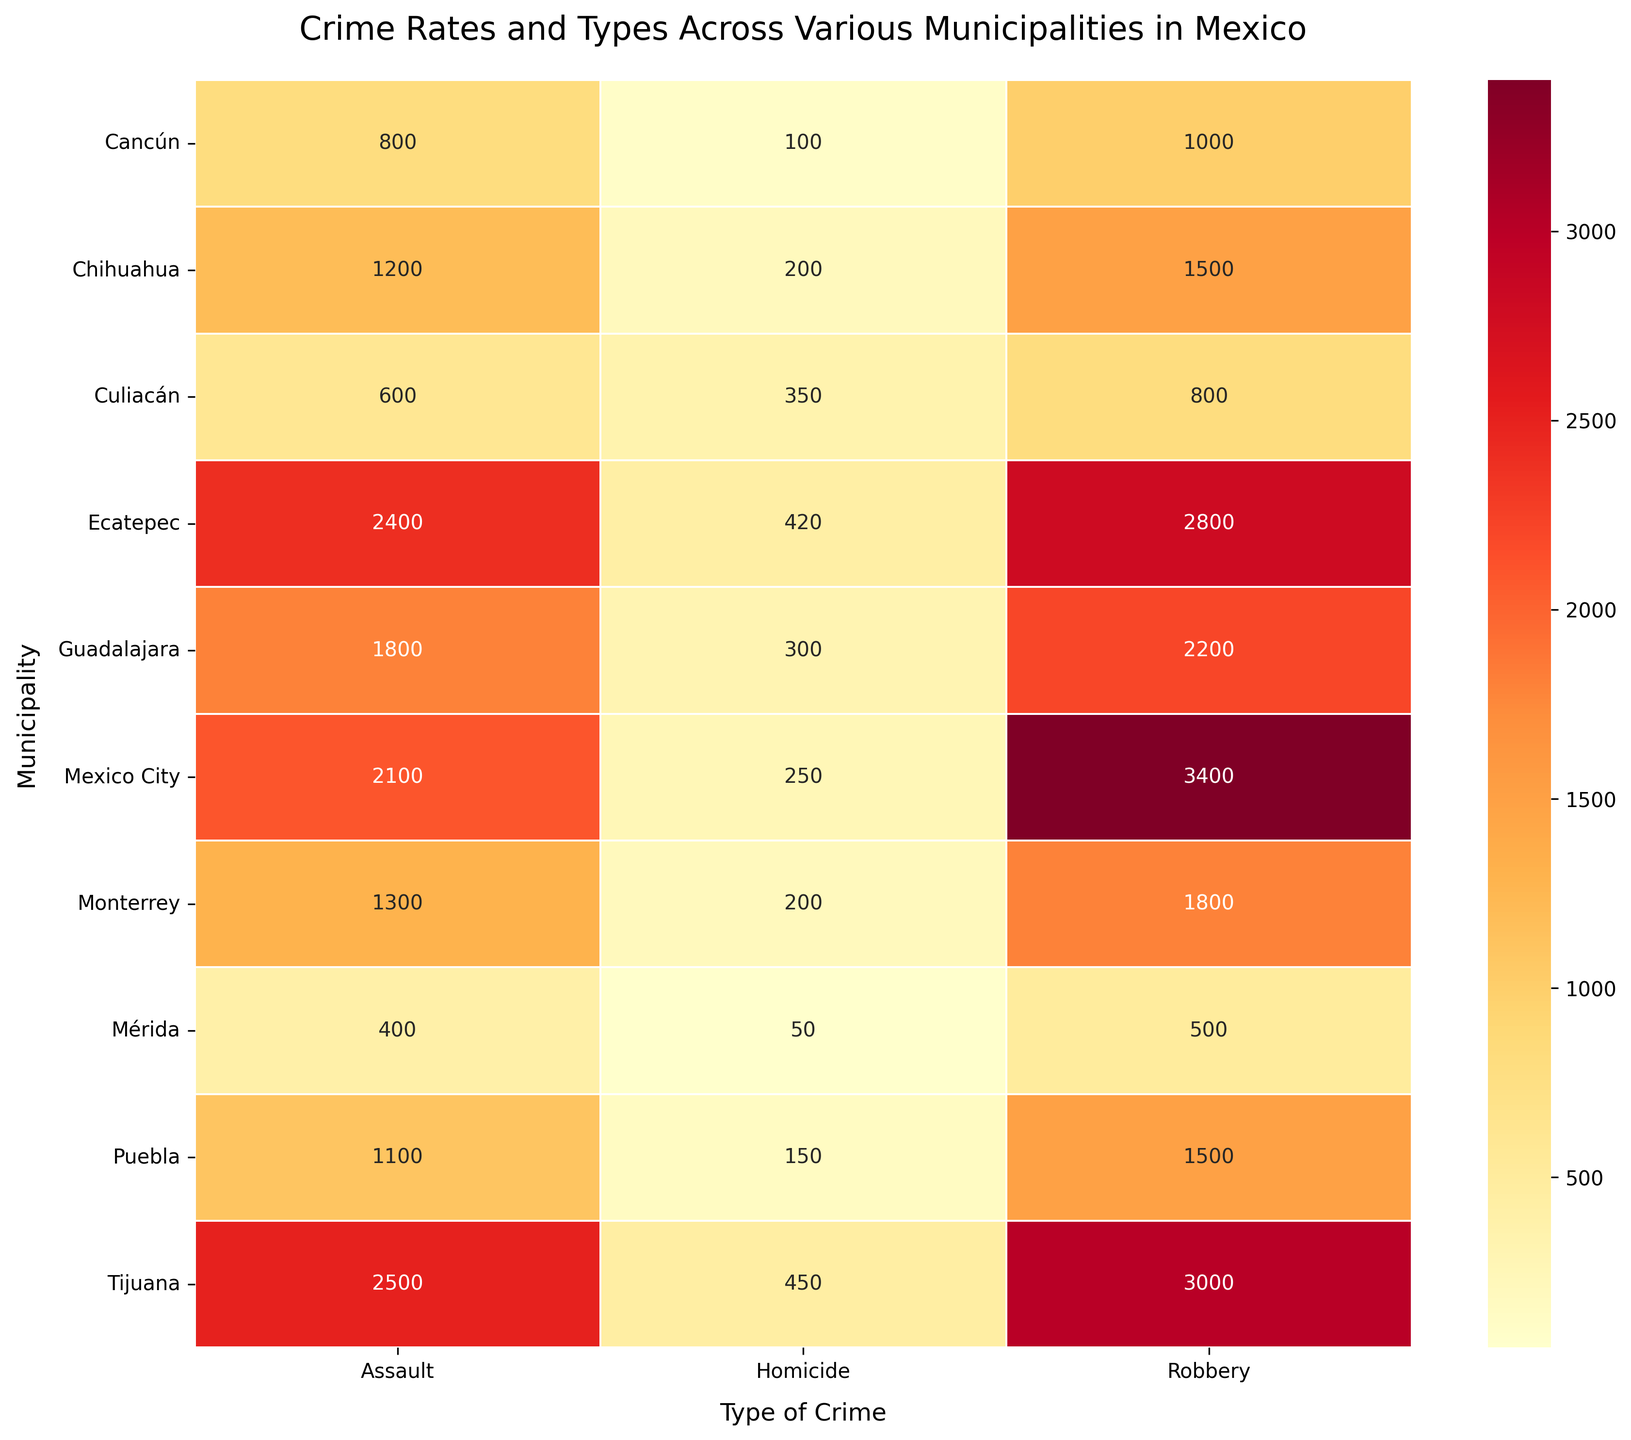How many types of crime are represented in the heatmap? The heatmap visualizes data for three types of crime: Robbery, Assault, and Homicide as seen on the x-axis.
Answer: Three types of crime Which municipality has the highest number of homicides? By examining the "Homicide" column, Tijuana has the highest number of incidents with 450.
Answer: Tijuana What is the total number of robbery incidents in Ecatepec and Guadalajara combined? Ecatepec has 2800 robbery incidents and Guadalajara has 2200. Summing them gives 2800 + 2200 = 5000.
Answer: 5000 Among Monterrey and Puebla, which municipality has fewer total number of crimes? Add the incidents for each type of crime for Monterrey: 1800 (Robbery) + 1300 (Assault) + 200 (Homicide) = 3300. For Puebla: 1500 (Robbery) + 1100 (Assault) + 150 (Homicide) = 2750. Puebla has fewer total incidents.
Answer: Puebla What is the most common type of crime in Mexico City? In the rows for Mexico City, the highest number of incidents is associated with robbery (3400).
Answer: Robbery Which type of crime shows the largest variation across all municipalities? By visually scanning the heatmap colors in each crime column, robbery shows the largest variation, with some municipalities having as high as 3400 incidents and others as low as 500.
Answer: Robbery How does the number of assault incidents in Tijuana compare to that in Guadalajara? Tijuana has 2500 assault incidents while Guadalajara has 1800, so Tijuana has more assault incidents.
Answer: Tijuana has more What is the average number of homicides across all municipalities depicted? Sum the numbers in the homicide column: 250 (Mexico City) + 300 (Guadalajara) + 200 (Monterrey) + 150 (Puebla) + 450 (Tijuana) + 420 (Ecatepec) + 100 (Cancún) + 50 (Mérida) + 200 (Chihuahua) + 350 (Culiacán) = 2470. There are 10 municipalities, so the average is 2470 / 10 = 247.
Answer: 247 Which municipality has the lowest number of total crime incidents? Sum incidents for each type of crime for each municipality and identify the lowest. Mérida has 500 + 400 + 50 = 950, which is the lowest total among the municipalities.
Answer: Mérida 